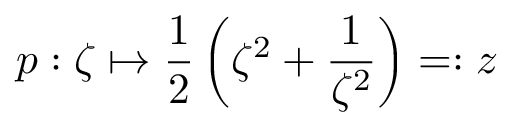<formula> <loc_0><loc_0><loc_500><loc_500>p \colon \zeta \mapsto \frac { 1 } { 2 } \left ( \zeta ^ { 2 } + \frac { 1 } { \zeta ^ { 2 } } \right ) = \colon z</formula> 